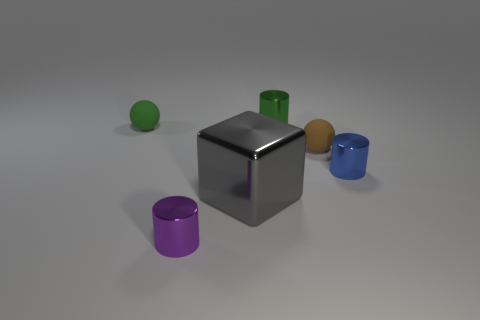Add 1 green objects. How many objects exist? 7 Subtract all cubes. How many objects are left? 5 Subtract all brown rubber objects. Subtract all gray metal cylinders. How many objects are left? 5 Add 3 balls. How many balls are left? 5 Add 6 purple cylinders. How many purple cylinders exist? 7 Subtract 0 cyan cylinders. How many objects are left? 6 